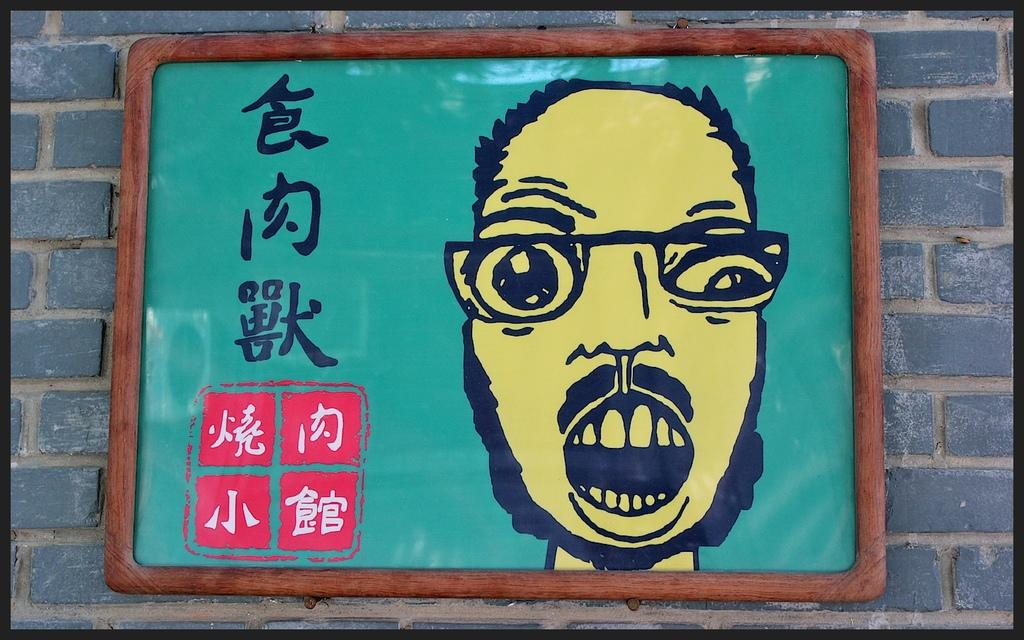What is the main subject in the center of the picture? There is a frame in the center of the picture. How is the frame positioned in the image? The frame is attached to a wall. What can be seen inside the frame? There is text and a human face inside the frame. What is the color of the border around the picture? The picture has a black border. How many frogs are sitting on top of the frame in the image? There are no frogs present in the image, and therefore no frogs can be seen sitting on top of the frame. 